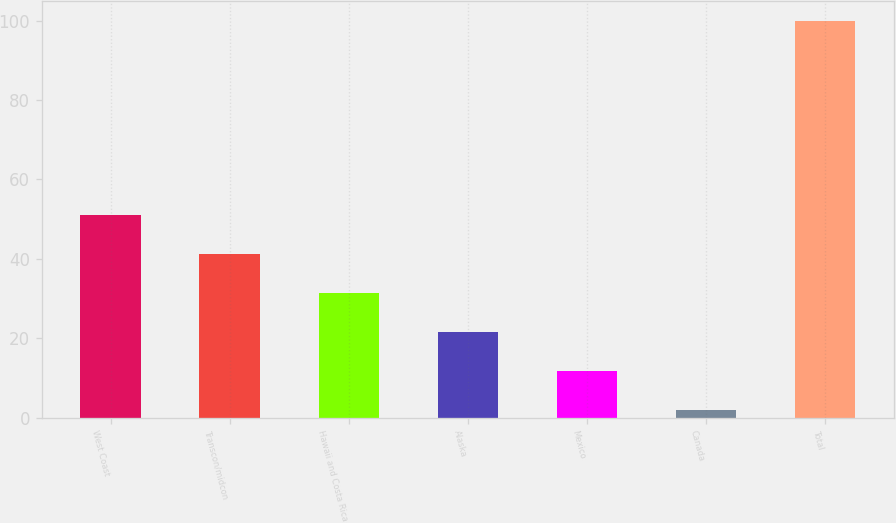Convert chart. <chart><loc_0><loc_0><loc_500><loc_500><bar_chart><fcel>West Coast<fcel>Transcon/midcon<fcel>Hawaii and Costa Rica<fcel>Alaska<fcel>Mexico<fcel>Canada<fcel>Total<nl><fcel>51<fcel>41.2<fcel>31.4<fcel>21.6<fcel>11.8<fcel>2<fcel>100<nl></chart> 